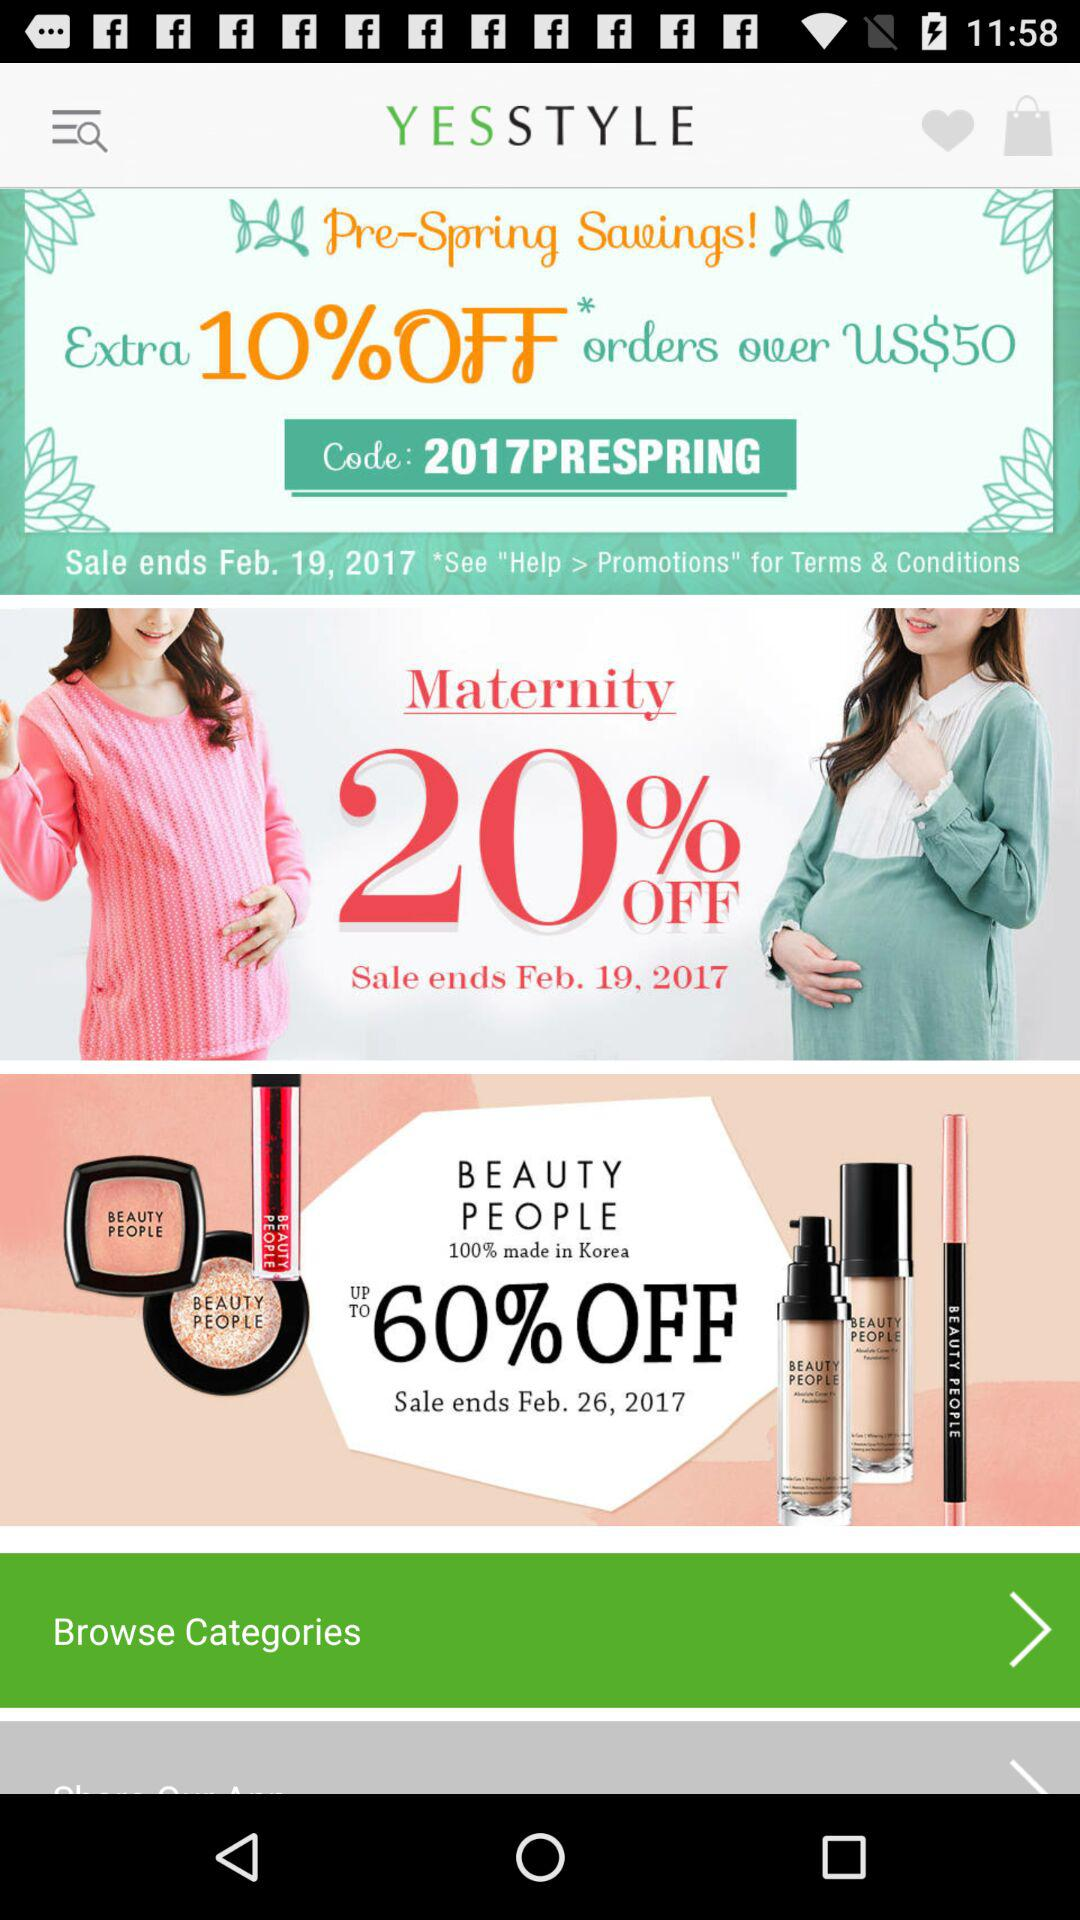What is the name of the application? The name of the application is "YESSTYLE". 